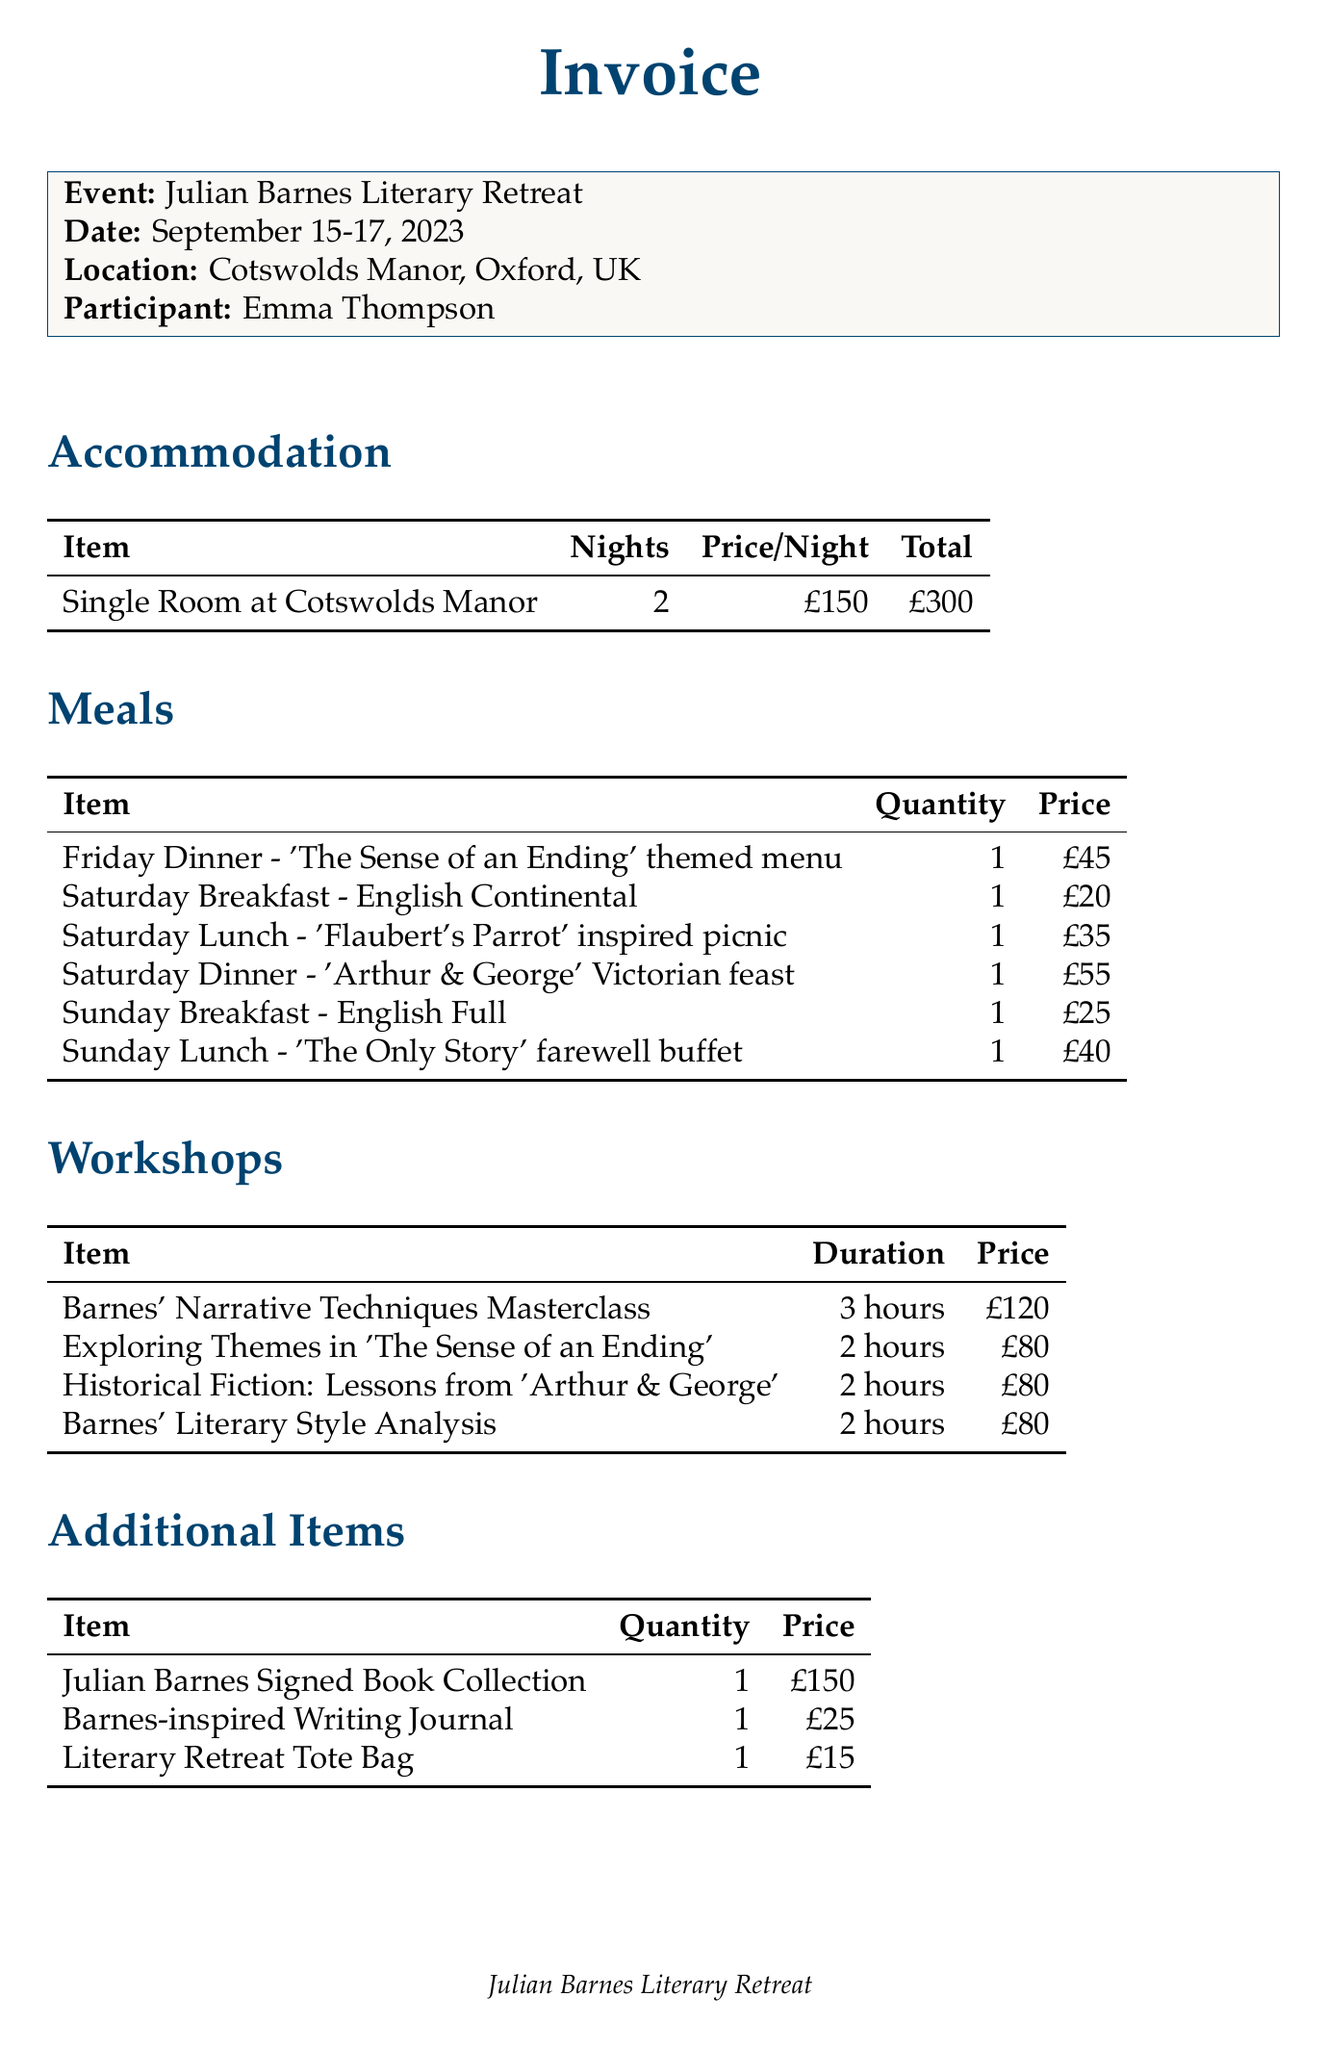What is the event name? The event name is specified in the invoice details.
Answer: Julian Barnes Literary Retreat What are the dates of the retreat? The retreat dates are listed under the invoice details section.
Answer: September 15-17, 2023 How much is the single room per night? The price per night for accommodation is detailed in the accommodation section.
Answer: £150 What is the total cost for the two-night stay? The total cost is calculated by multiplying the price per night by the number of nights.
Answer: £300 How many workshops are mentioned in the invoice? The number of workshops can be counted in the workshops section.
Answer: 4 What is the total price of the meals? The total price of the meals is the sum of all meal costs listed.
Answer: £215 What discount was offered for early bird booking? The discount amount for early bird booking is listed in the discounts section.
Answer: -£50 What is the total cost of the additional items? The total cost includes summing all additional items prices listed.
Answer: £190 What is the total amount due after discounts? The amount due is calculated by subtracting the total discounts from the total cost before discounts.
Answer: £1020 